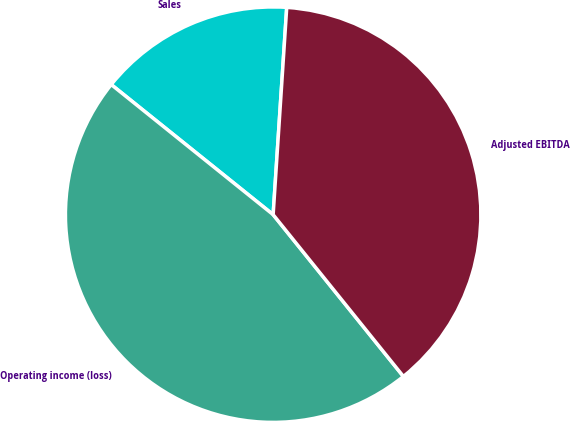Convert chart. <chart><loc_0><loc_0><loc_500><loc_500><pie_chart><fcel>Sales<fcel>Operating income (loss)<fcel>Adjusted EBITDA<nl><fcel>15.27%<fcel>46.56%<fcel>38.17%<nl></chart> 